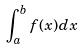Convert formula to latex. <formula><loc_0><loc_0><loc_500><loc_500>\int _ { a } ^ { b } f ( x ) d x</formula> 